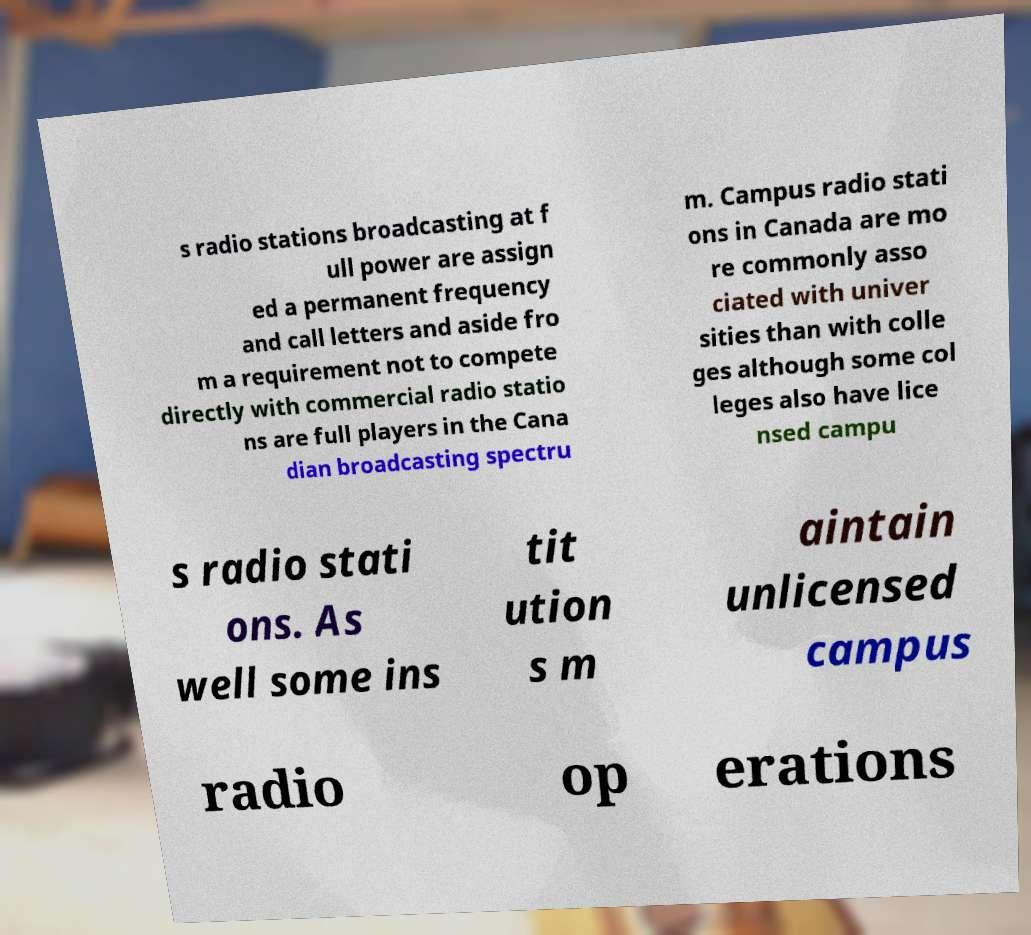What messages or text are displayed in this image? I need them in a readable, typed format. s radio stations broadcasting at f ull power are assign ed a permanent frequency and call letters and aside fro m a requirement not to compete directly with commercial radio statio ns are full players in the Cana dian broadcasting spectru m. Campus radio stati ons in Canada are mo re commonly asso ciated with univer sities than with colle ges although some col leges also have lice nsed campu s radio stati ons. As well some ins tit ution s m aintain unlicensed campus radio op erations 